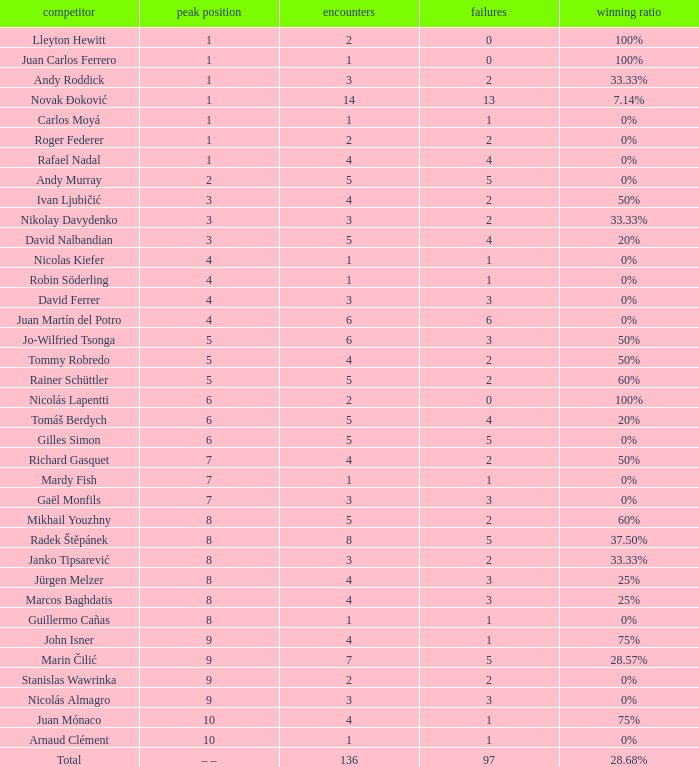What is the largest number Lost to david nalbandian with a Win Rate of 20%? 4.0. 